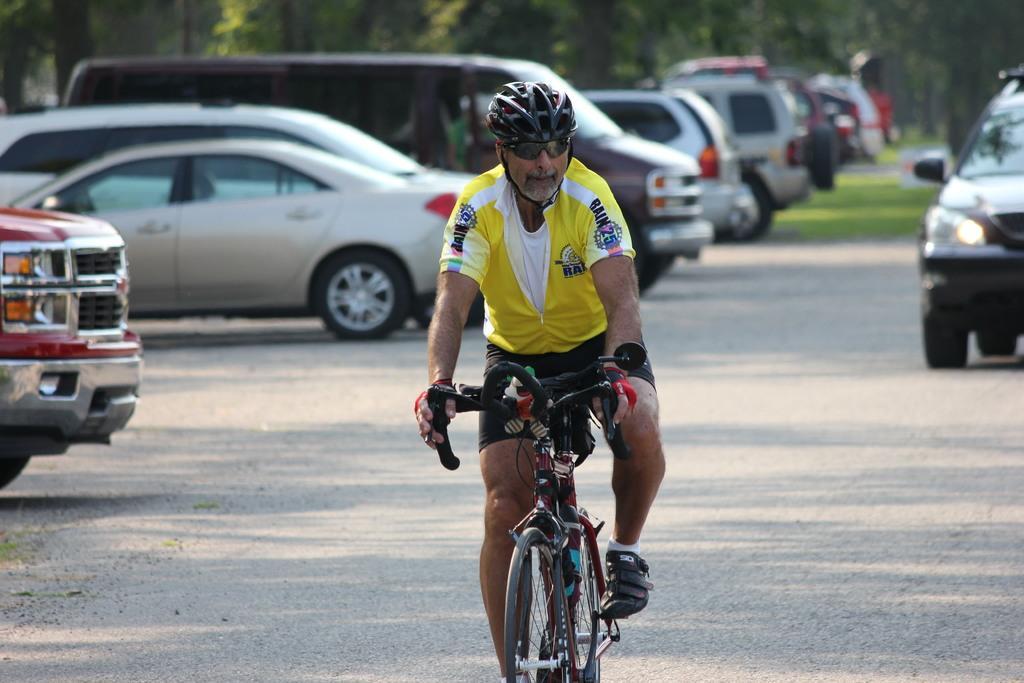Could you give a brief overview of what you see in this image? In the image we can see there is a man who is riding bicycle on the road and cars are parked on the road. 